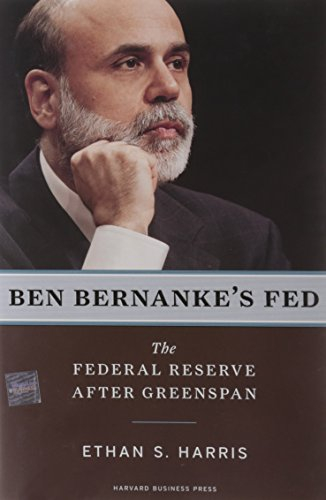Who is the author of this book?
Answer the question using a single word or phrase. Ethan S. Harris What is the title of this book? Ben Bernanke's Fed: The Federal Reserve After Greenspan What type of book is this? Business & Money Is this a financial book? Yes Is this a fitness book? No 